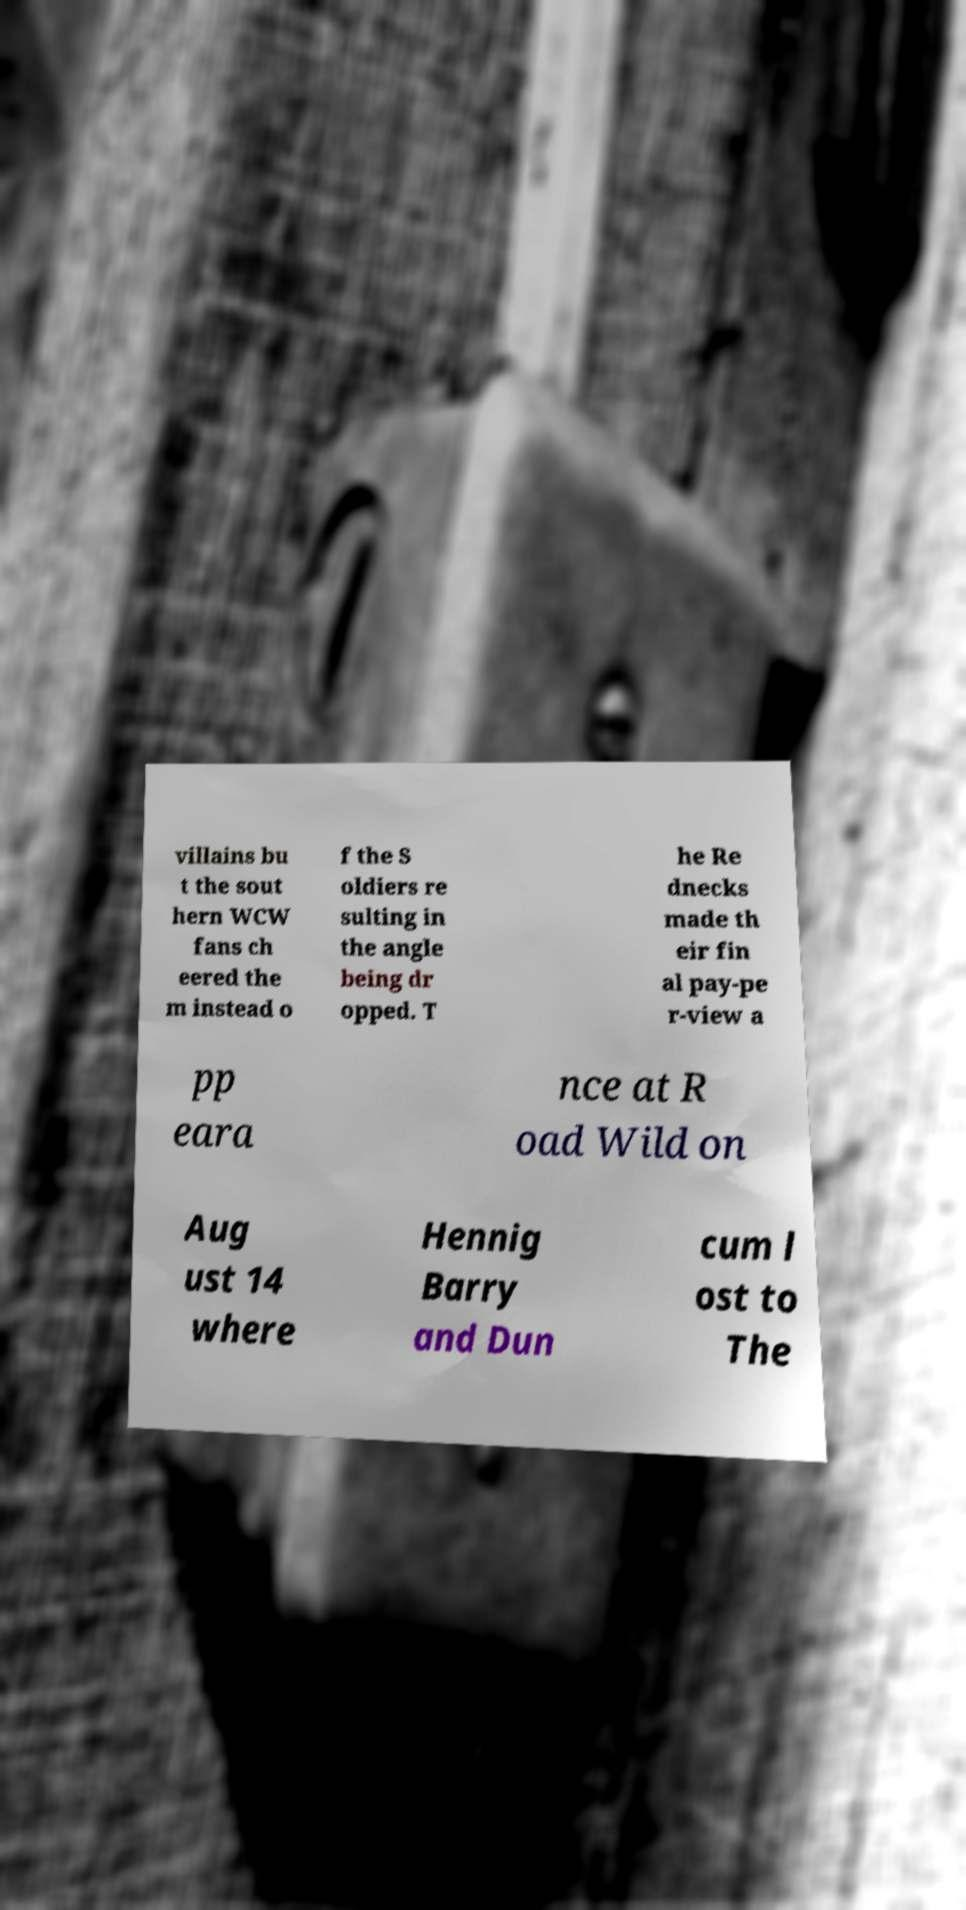There's text embedded in this image that I need extracted. Can you transcribe it verbatim? villains bu t the sout hern WCW fans ch eered the m instead o f the S oldiers re sulting in the angle being dr opped. T he Re dnecks made th eir fin al pay-pe r-view a pp eara nce at R oad Wild on Aug ust 14 where Hennig Barry and Dun cum l ost to The 